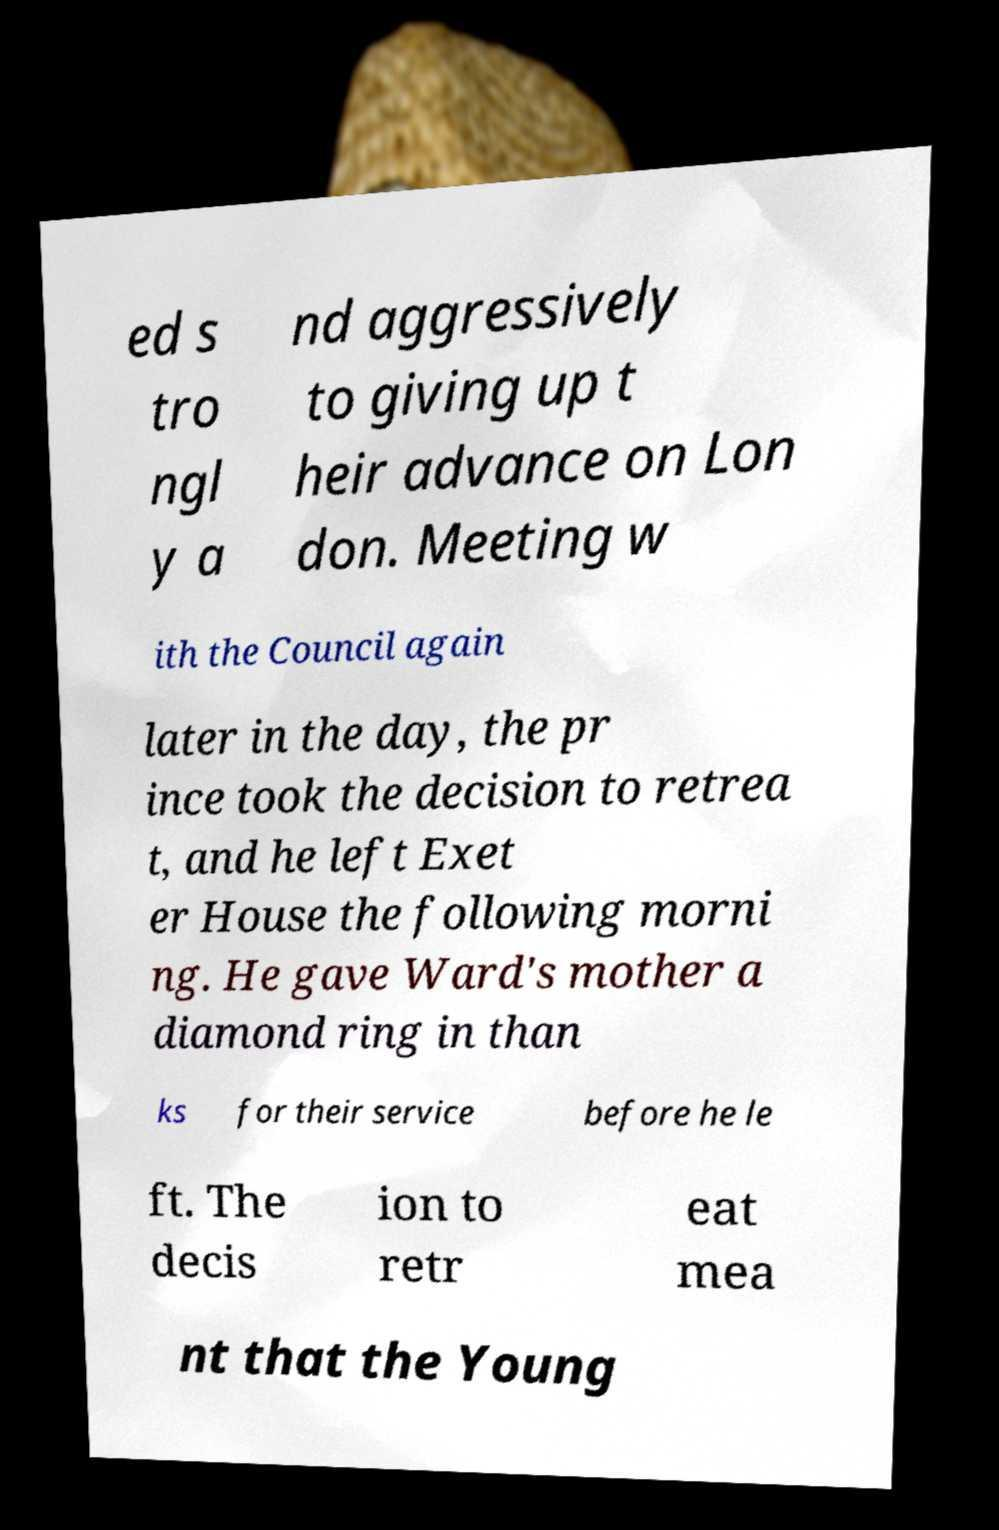Please read and relay the text visible in this image. What does it say? ed s tro ngl y a nd aggressively to giving up t heir advance on Lon don. Meeting w ith the Council again later in the day, the pr ince took the decision to retrea t, and he left Exet er House the following morni ng. He gave Ward's mother a diamond ring in than ks for their service before he le ft. The decis ion to retr eat mea nt that the Young 